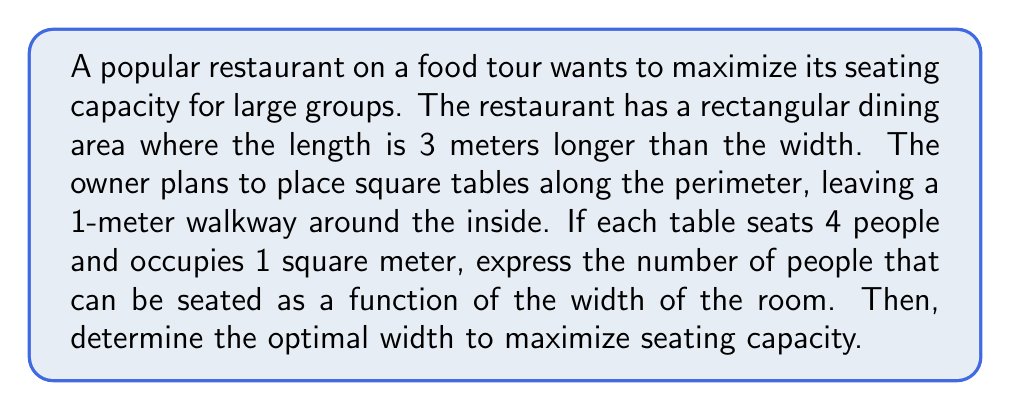Solve this math problem. Let's approach this step-by-step:

1) Let $w$ be the width of the room in meters. Then the length is $w + 3$ meters.

2) The perimeter where tables can be placed is:
   $2(w-2) + 2((w+3)-2) = 2w-4 + 2w+2 = 4w-2$ meters

3) Since each table occupies 1 meter, the number of tables is equal to the perimeter length: $4w-2$

4) Each table seats 4 people, so the seating capacity is:
   $P(w) = 4(4w-2) = 16w-8$

5) To find the maximum, we need to consider the constraints. The width must be positive and less than the length:
   $0 < w < w+3$

6) To find the optimal width, we need to find the maximum value of $P(w)$ within these constraints. Since $P(w)$ is a linear function, its maximum will occur at the largest possible value of $w$.

7) The largest possible value of $w$ is just under $w+3$. Let's say it's $w+2.9$ to leave a small gap.

8) Solving $w = w+2.9$, we get $w = 2.9$ meters.

9) Rounding down to ensure we don't exceed the length, the optimal width is 2.8 meters.

10) The optimal seating capacity is:
    $P(2.8) = 16(2.8)-8 = 36.8$

11) Since we can only seat whole people, we round down to 36.
Answer: 36 people 